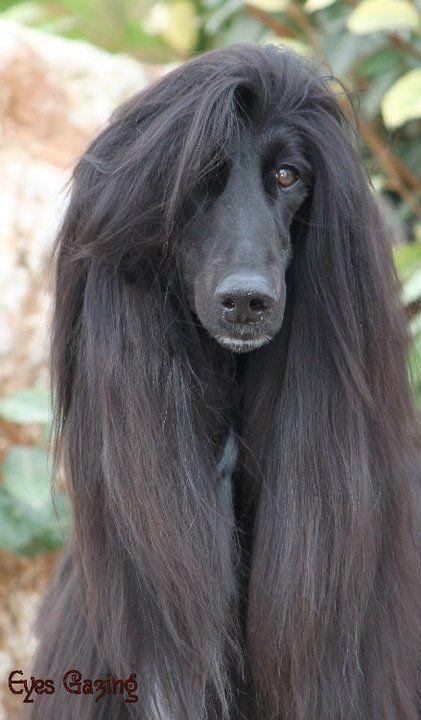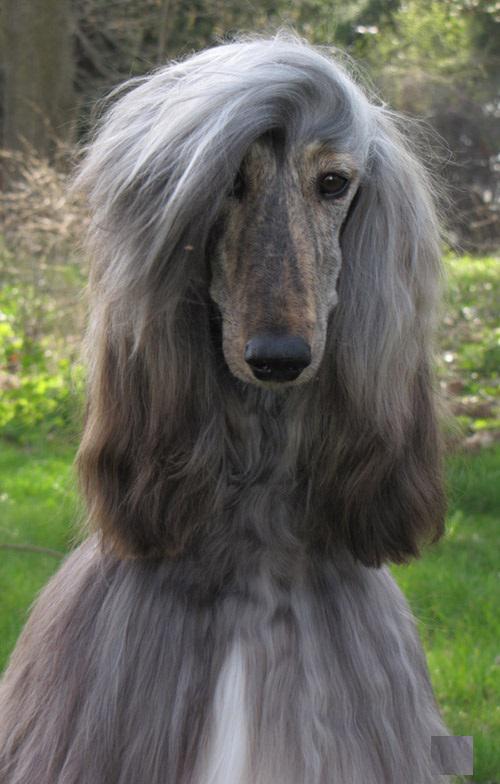The first image is the image on the left, the second image is the image on the right. For the images shown, is this caption "In one image there is a lone afghan hound standing outside and facing the left side of the image." true? Answer yes or no. No. The first image is the image on the left, the second image is the image on the right. Examine the images to the left and right. Is the description "At least one image is of a dog from the shoulders up, looking toward the camera." accurate? Answer yes or no. Yes. 